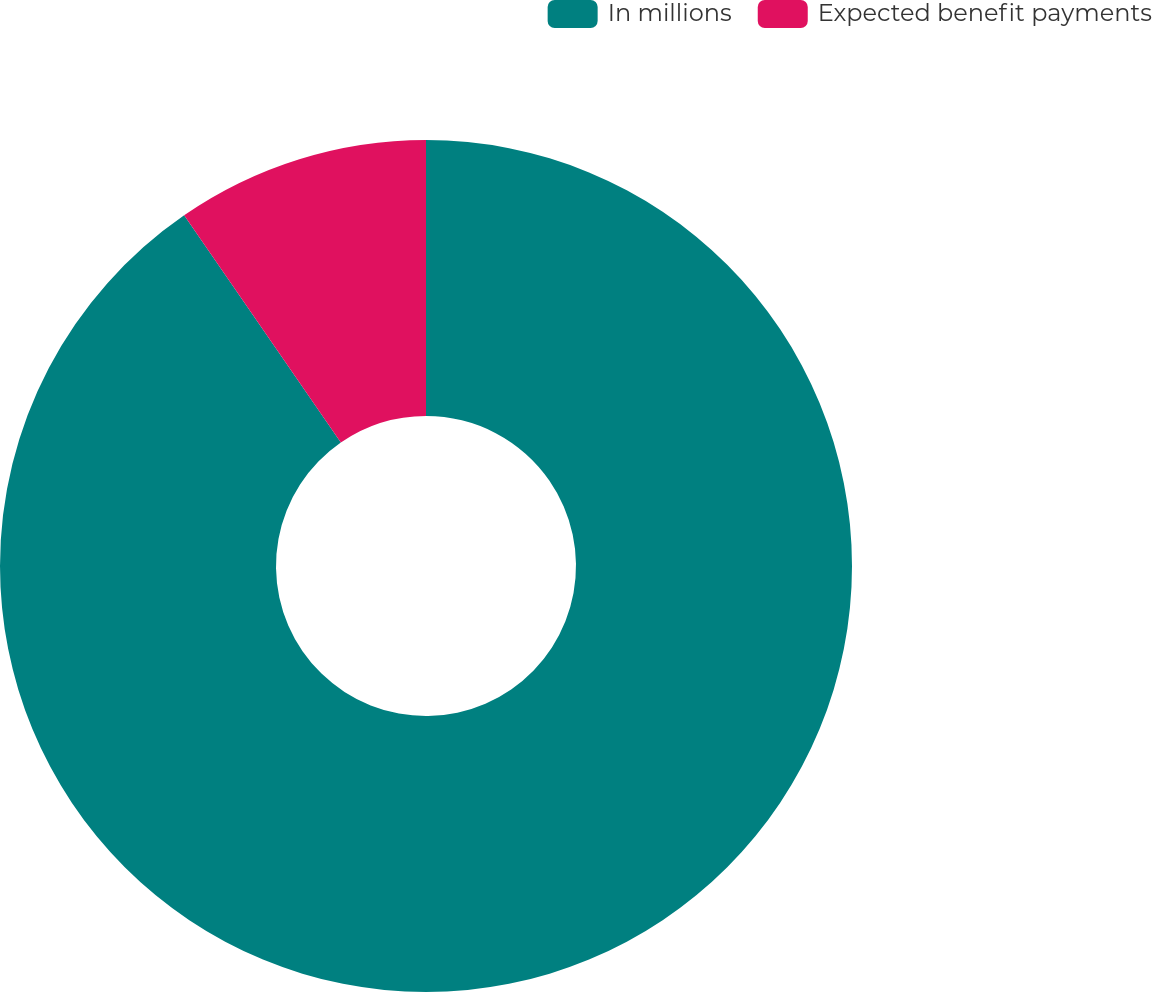<chart> <loc_0><loc_0><loc_500><loc_500><pie_chart><fcel>In millions<fcel>Expected benefit payments<nl><fcel>90.39%<fcel>9.61%<nl></chart> 